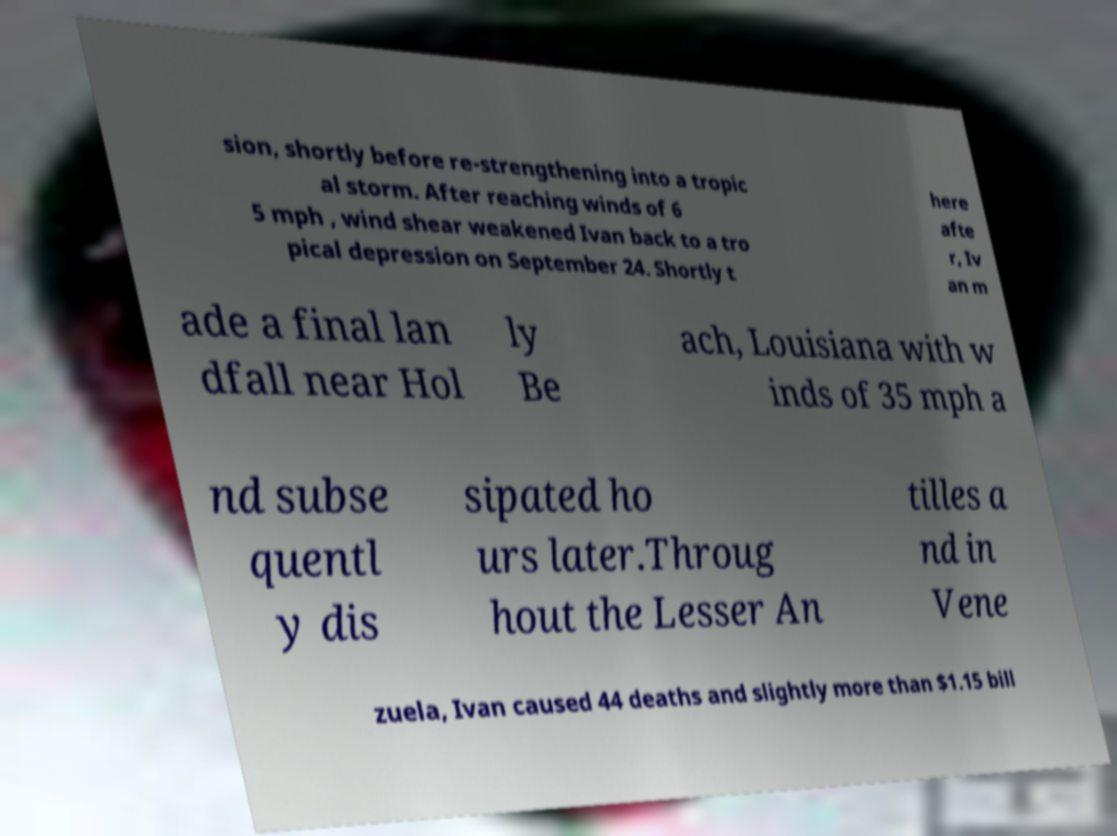I need the written content from this picture converted into text. Can you do that? sion, shortly before re-strengthening into a tropic al storm. After reaching winds of 6 5 mph , wind shear weakened Ivan back to a tro pical depression on September 24. Shortly t here afte r, Iv an m ade a final lan dfall near Hol ly Be ach, Louisiana with w inds of 35 mph a nd subse quentl y dis sipated ho urs later.Throug hout the Lesser An tilles a nd in Vene zuela, Ivan caused 44 deaths and slightly more than $1.15 bill 